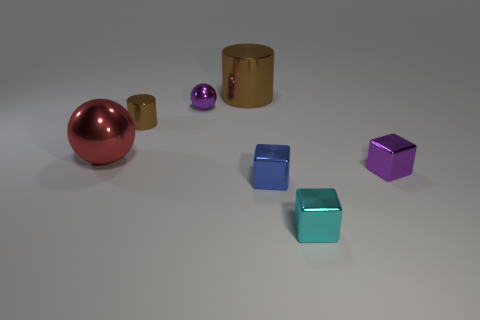Is the number of small spheres behind the tiny blue cube less than the number of big red shiny spheres?
Your answer should be compact. No. There is a purple thing to the right of the brown object on the right side of the brown metallic cylinder that is to the left of the big brown cylinder; what is its shape?
Give a very brief answer. Cube. Do the small shiny cylinder and the big cylinder have the same color?
Offer a terse response. Yes. Are there more red metal objects than green things?
Your answer should be compact. Yes. How many other objects are there of the same material as the big brown cylinder?
Offer a very short reply. 6. How many objects are either gray cylinders or big things behind the red shiny thing?
Provide a succinct answer. 1. Is the number of tiny yellow metal cubes less than the number of cyan cubes?
Your answer should be very brief. Yes. What color is the large metal thing that is on the right side of the purple object that is behind the tiny block that is behind the small blue thing?
Your answer should be very brief. Brown. Do the small blue block and the small cyan block have the same material?
Provide a succinct answer. Yes. How many brown shiny things are in front of the large brown shiny thing?
Offer a very short reply. 1. 